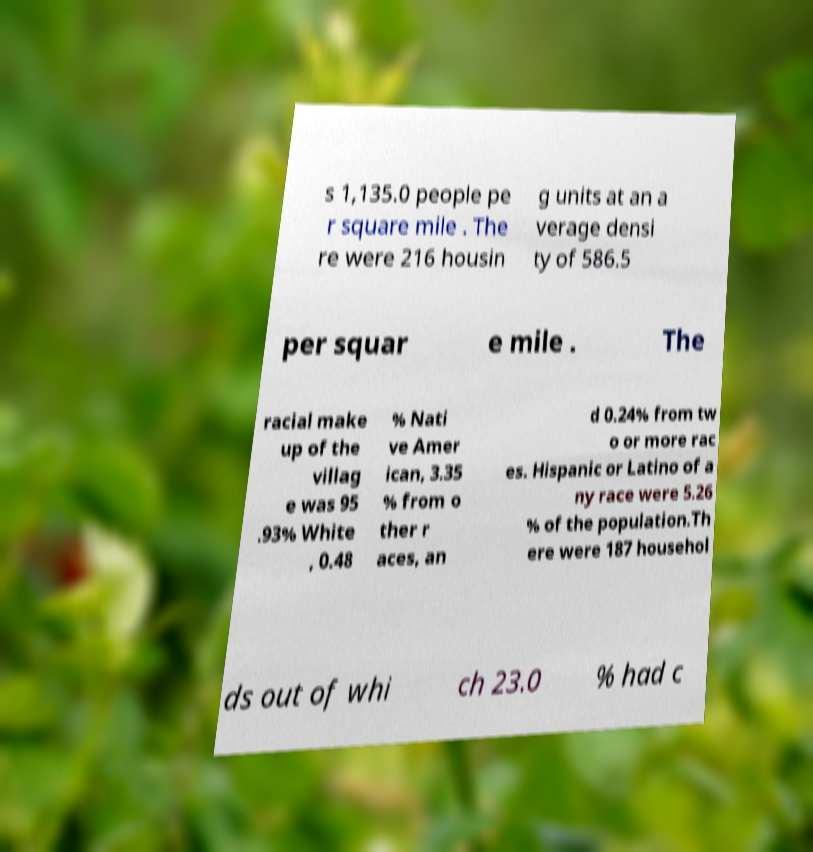For documentation purposes, I need the text within this image transcribed. Could you provide that? s 1,135.0 people pe r square mile . The re were 216 housin g units at an a verage densi ty of 586.5 per squar e mile . The racial make up of the villag e was 95 .93% White , 0.48 % Nati ve Amer ican, 3.35 % from o ther r aces, an d 0.24% from tw o or more rac es. Hispanic or Latino of a ny race were 5.26 % of the population.Th ere were 187 househol ds out of whi ch 23.0 % had c 